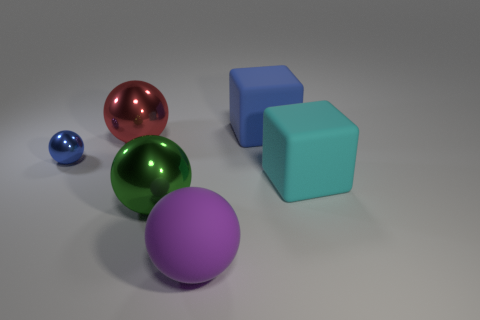What material is the other thing that is the same color as the tiny shiny thing?
Your response must be concise. Rubber. Is there another big purple object that has the same shape as the purple thing?
Keep it short and to the point. No. There is a small shiny sphere; how many big blue rubber blocks are right of it?
Your answer should be very brief. 1. What is the material of the blue object left of the large metallic ball that is in front of the cyan matte cube?
Offer a terse response. Metal. There is a green thing that is the same size as the red shiny object; what is it made of?
Your answer should be very brief. Metal. Are there any blue spheres of the same size as the green thing?
Provide a short and direct response. No. There is a matte object that is in front of the big green thing; what is its color?
Your response must be concise. Purple. Are there any large cubes to the left of the blue thing that is on the left side of the big purple ball?
Offer a very short reply. No. How many other things are the same color as the small metal object?
Your response must be concise. 1. There is a blue thing that is on the right side of the big red thing; does it have the same size as the rubber block that is in front of the big red object?
Your answer should be very brief. Yes. 